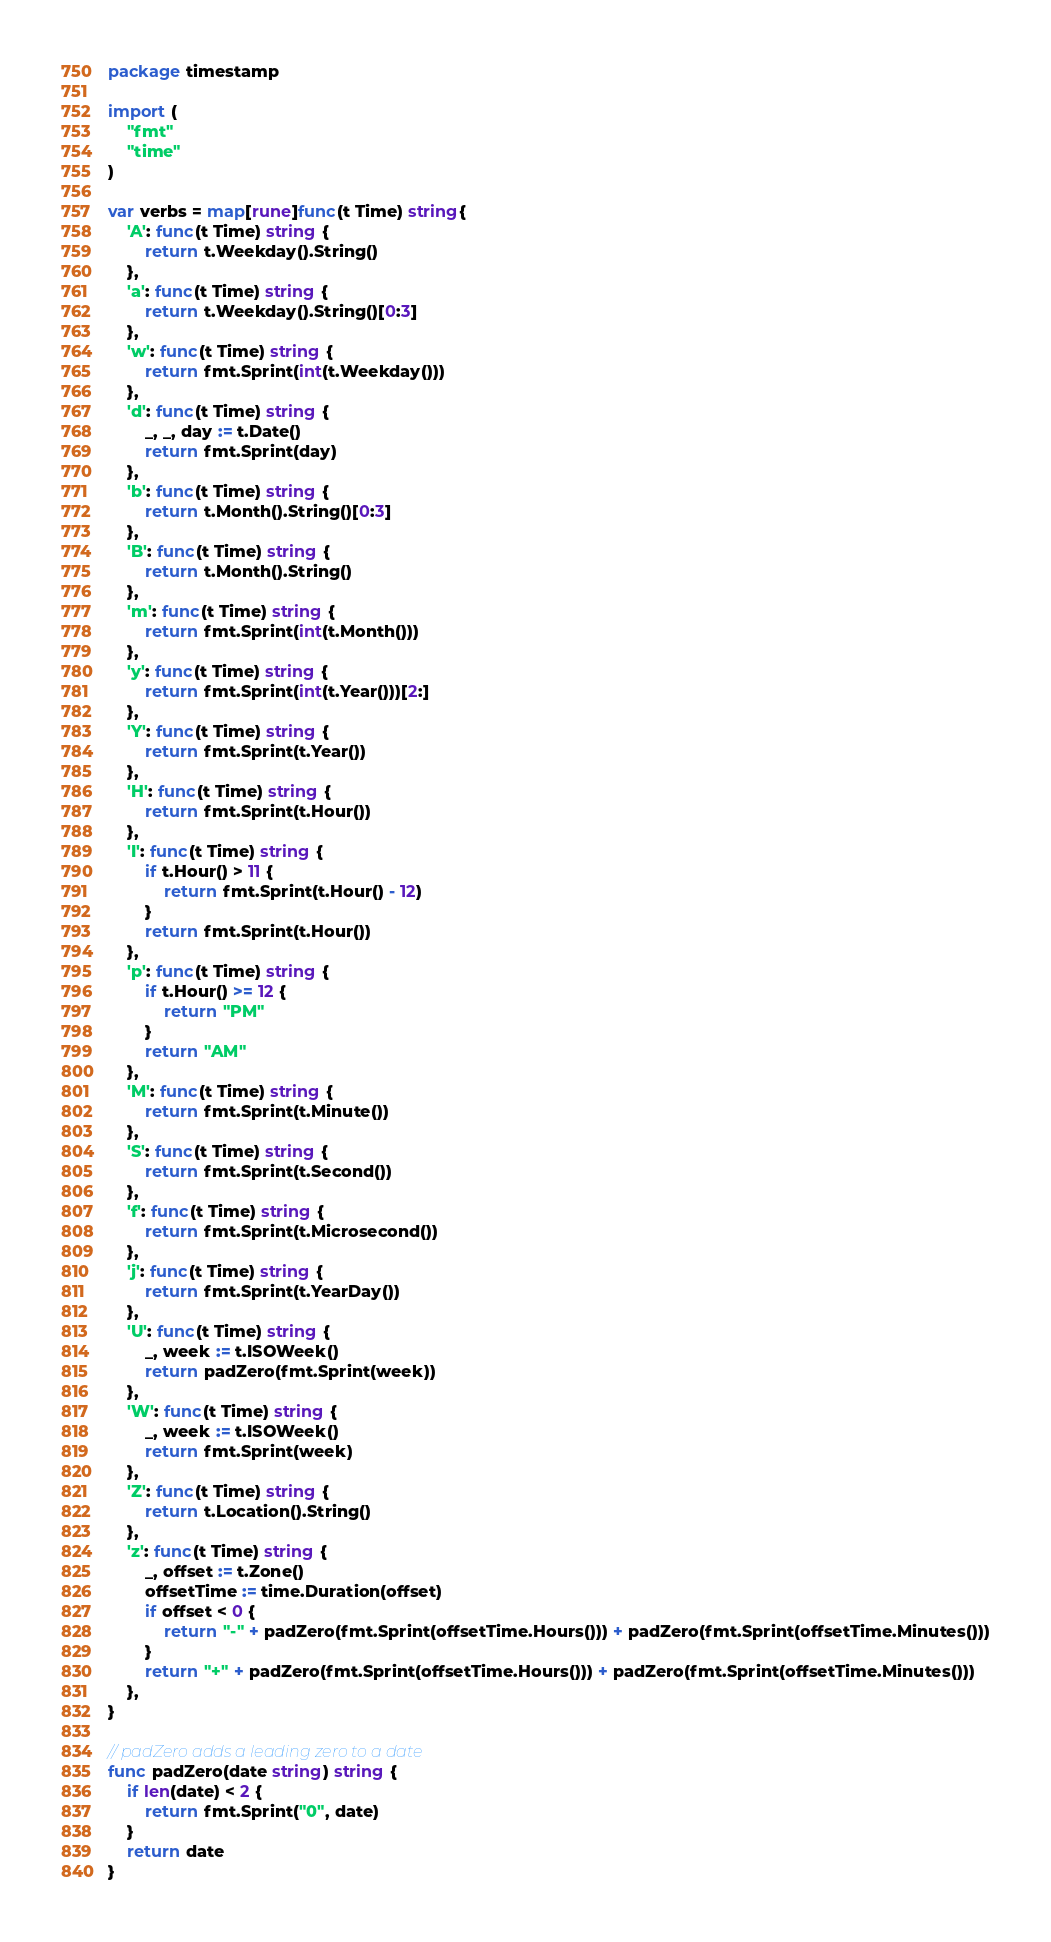<code> <loc_0><loc_0><loc_500><loc_500><_Go_>package timestamp

import (
	"fmt"
	"time"
)

var verbs = map[rune]func(t Time) string{
	'A': func(t Time) string {
		return t.Weekday().String()
	},
	'a': func(t Time) string {
		return t.Weekday().String()[0:3]
	},
	'w': func(t Time) string {
		return fmt.Sprint(int(t.Weekday()))
	},
	'd': func(t Time) string {
		_, _, day := t.Date()
		return fmt.Sprint(day)
	},
	'b': func(t Time) string {
		return t.Month().String()[0:3]
	},
	'B': func(t Time) string {
		return t.Month().String()
	},
	'm': func(t Time) string {
		return fmt.Sprint(int(t.Month()))
	},
	'y': func(t Time) string {
		return fmt.Sprint(int(t.Year()))[2:]
	},
	'Y': func(t Time) string {
		return fmt.Sprint(t.Year())
	},
	'H': func(t Time) string {
		return fmt.Sprint(t.Hour())
	},
	'I': func(t Time) string {
		if t.Hour() > 11 {
			return fmt.Sprint(t.Hour() - 12)
		}
		return fmt.Sprint(t.Hour())
	},
	'p': func(t Time) string {
		if t.Hour() >= 12 {
			return "PM"
		}
		return "AM"
	},
	'M': func(t Time) string {
		return fmt.Sprint(t.Minute())
	},
	'S': func(t Time) string {
		return fmt.Sprint(t.Second())
	},
	'f': func(t Time) string {
		return fmt.Sprint(t.Microsecond())
	},
	'j': func(t Time) string {
		return fmt.Sprint(t.YearDay())
	},
	'U': func(t Time) string {
		_, week := t.ISOWeek()
		return padZero(fmt.Sprint(week))
	},
	'W': func(t Time) string {
		_, week := t.ISOWeek()
		return fmt.Sprint(week)
	},
	'Z': func(t Time) string {
		return t.Location().String()
	},
	'z': func(t Time) string {
		_, offset := t.Zone()
		offsetTime := time.Duration(offset)
		if offset < 0 {
			return "-" + padZero(fmt.Sprint(offsetTime.Hours())) + padZero(fmt.Sprint(offsetTime.Minutes()))
		}
		return "+" + padZero(fmt.Sprint(offsetTime.Hours())) + padZero(fmt.Sprint(offsetTime.Minutes()))
	},
}

// padZero adds a leading zero to a date
func padZero(date string) string {
	if len(date) < 2 {
		return fmt.Sprint("0", date)
	}
	return date
}
</code> 